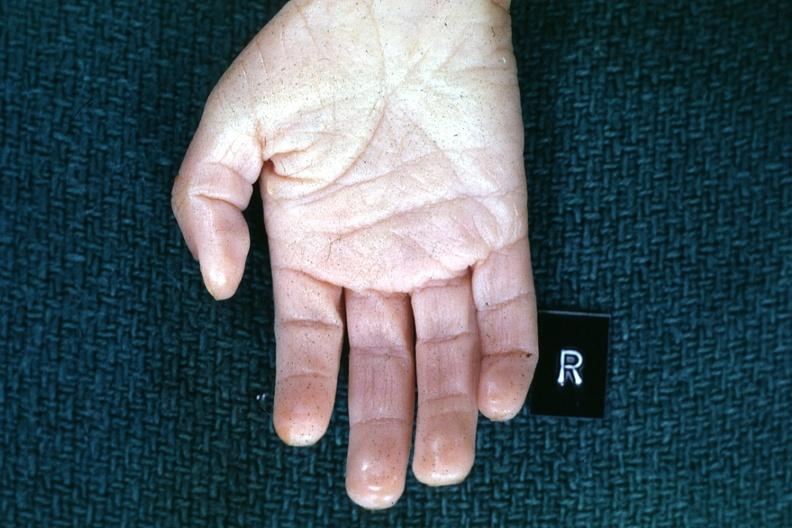what does this image show?
Answer the question using a single word or phrase. Right hand 